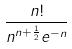Convert formula to latex. <formula><loc_0><loc_0><loc_500><loc_500>\frac { n ! } { n ^ { n + \frac { 1 } { 2 } } e ^ { - n } }</formula> 